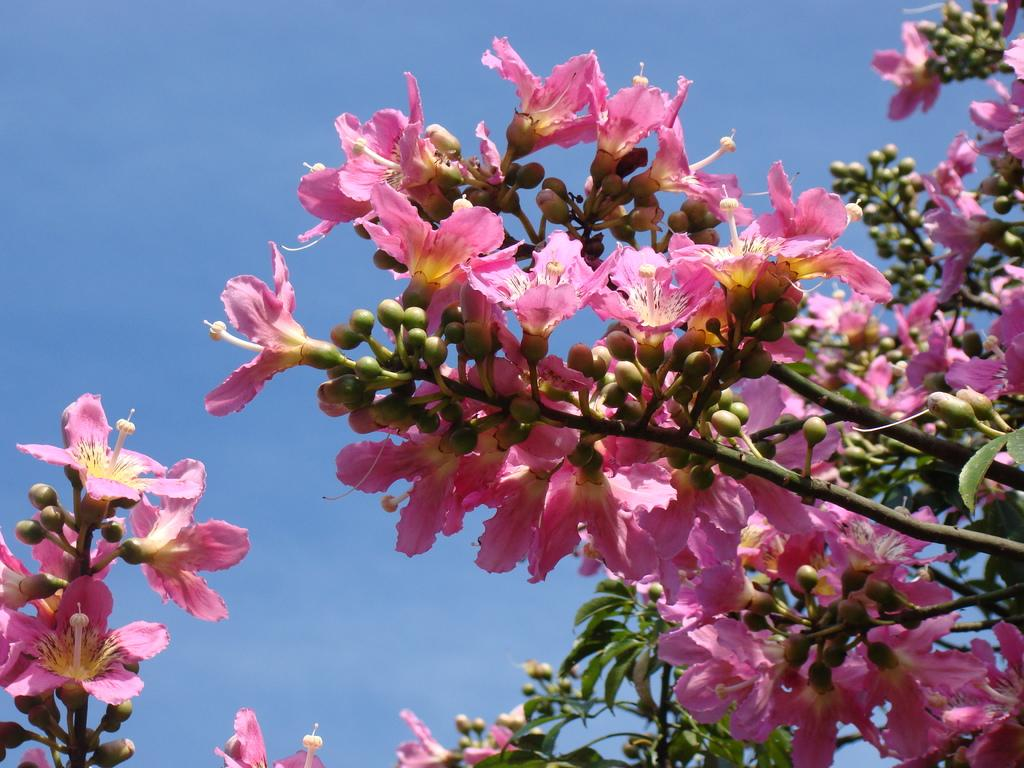What type of plants can be seen in the image? There are flowers in the image. What color are the flowers? The flowers are pink in color. What else can be seen in the image besides the flowers? There are leaves in the image. What stage of growth are the flowers in? There are small buds on the branches of the flower plants. What type of payment is required to go on vacation in the image? There is no mention of payment or vacation in the image; it features flowers and leaves. 